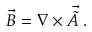<formula> <loc_0><loc_0><loc_500><loc_500>\vec { B } = \nabla \times \vec { \tilde { A } } \, .</formula> 